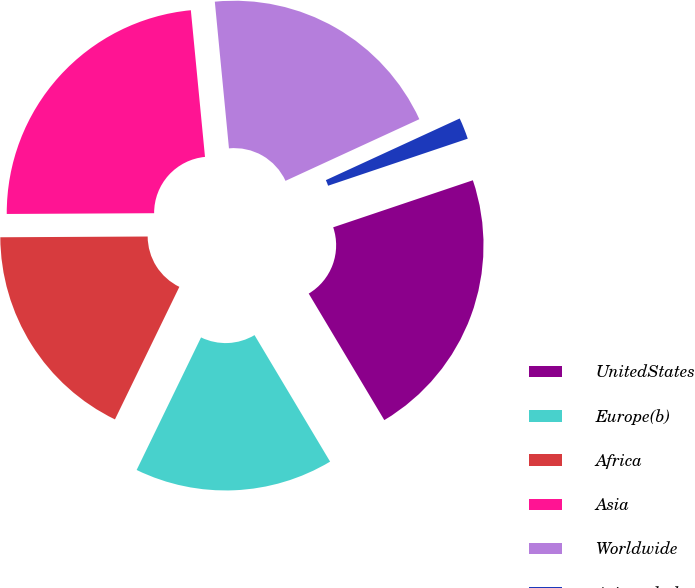<chart> <loc_0><loc_0><loc_500><loc_500><pie_chart><fcel>UnitedStates<fcel>Europe(b)<fcel>Africa<fcel>Asia<fcel>Worldwide<fcel>Asiaandother<nl><fcel>21.6%<fcel>15.77%<fcel>17.72%<fcel>23.55%<fcel>19.66%<fcel>1.7%<nl></chart> 